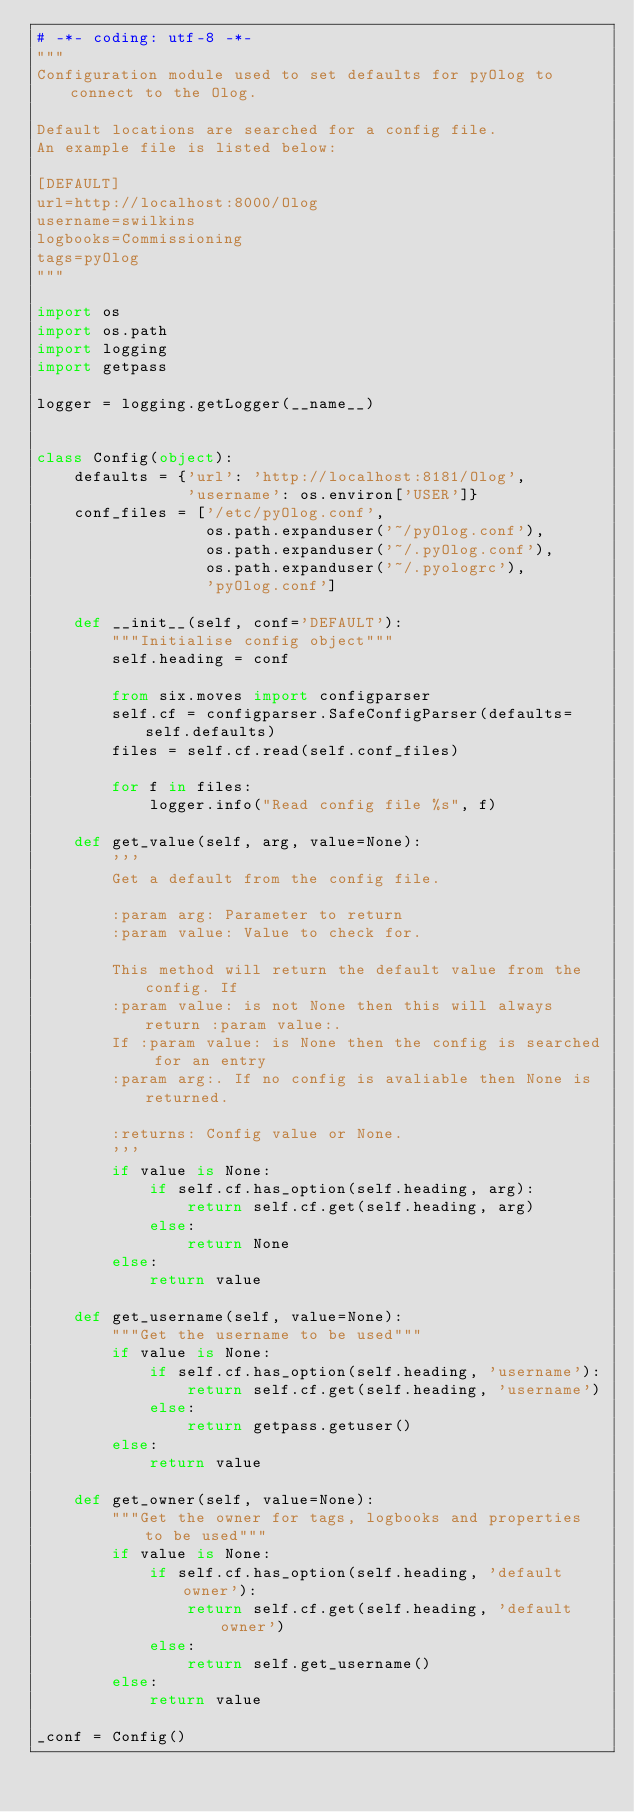<code> <loc_0><loc_0><loc_500><loc_500><_Python_># -*- coding: utf-8 -*-
"""
Configuration module used to set defaults for pyOlog to connect to the Olog.

Default locations are searched for a config file.
An example file is listed below:

[DEFAULT]
url=http://localhost:8000/Olog
username=swilkins
logbooks=Commissioning
tags=pyOlog
"""

import os
import os.path
import logging
import getpass

logger = logging.getLogger(__name__)


class Config(object):
    defaults = {'url': 'http://localhost:8181/Olog',
                'username': os.environ['USER']}
    conf_files = ['/etc/pyOlog.conf',
                  os.path.expanduser('~/pyOlog.conf'),
                  os.path.expanduser('~/.pyOlog.conf'),
                  os.path.expanduser('~/.pyologrc'),
                  'pyOlog.conf']

    def __init__(self, conf='DEFAULT'):
        """Initialise config object"""
        self.heading = conf

        from six.moves import configparser
        self.cf = configparser.SafeConfigParser(defaults=self.defaults)
        files = self.cf.read(self.conf_files)

        for f in files:
            logger.info("Read config file %s", f)

    def get_value(self, arg, value=None):
        '''
        Get a default from the config file.

        :param arg: Parameter to return
        :param value: Value to check for.

        This method will return the default value from the config. If
        :param value: is not None then this will always return :param value:.
        If :param value: is None then the config is searched for an entry
        :param arg:. If no config is avaliable then None is returned.

        :returns: Config value or None.
        '''
        if value is None:
            if self.cf.has_option(self.heading, arg):
                return self.cf.get(self.heading, arg)
            else:
                return None
        else:
            return value

    def get_username(self, value=None):
        """Get the username to be used"""
        if value is None:
            if self.cf.has_option(self.heading, 'username'):
                return self.cf.get(self.heading, 'username')
            else:
                return getpass.getuser()
        else:
            return value

    def get_owner(self, value=None):
        """Get the owner for tags, logbooks and properties to be used"""
        if value is None:
            if self.cf.has_option(self.heading, 'default owner'):
                return self.cf.get(self.heading, 'default owner')
            else:
                return self.get_username()
        else:
            return value

_conf = Config()
</code> 